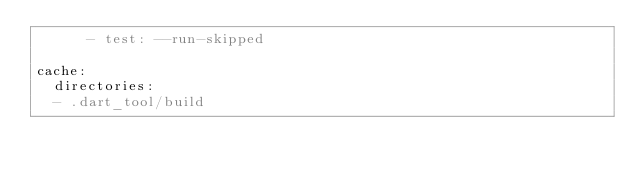Convert code to text. <code><loc_0><loc_0><loc_500><loc_500><_YAML_>      - test: --run-skipped

cache:
  directories:
  - .dart_tool/build
</code> 